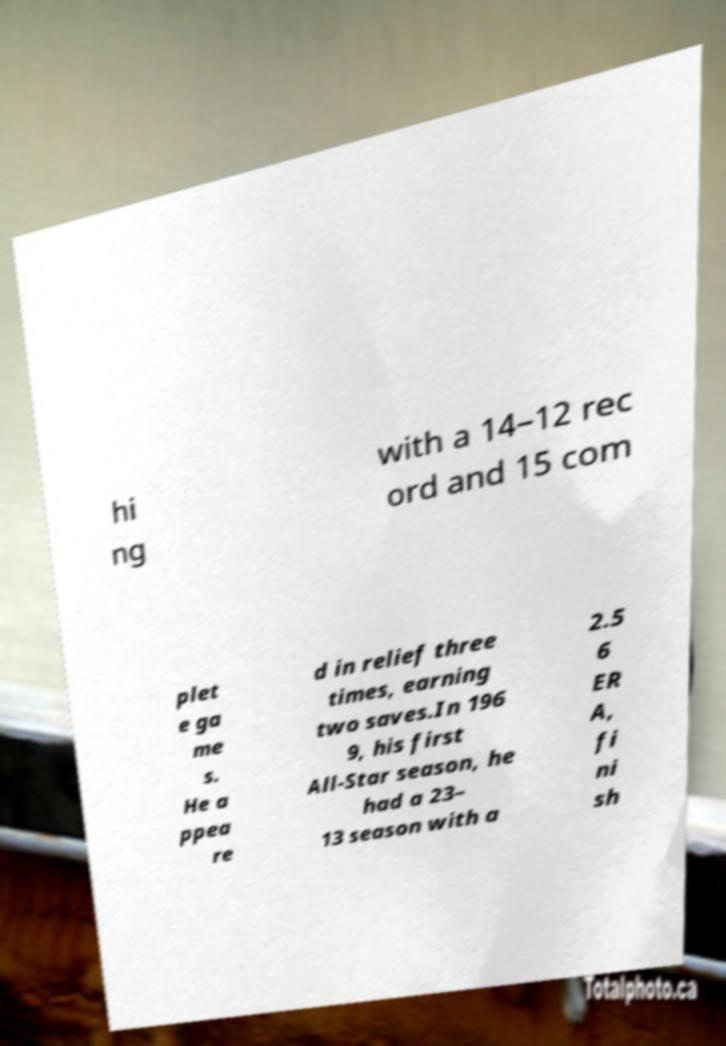Please read and relay the text visible in this image. What does it say? hi ng with a 14–12 rec ord and 15 com plet e ga me s. He a ppea re d in relief three times, earning two saves.In 196 9, his first All-Star season, he had a 23– 13 season with a 2.5 6 ER A, fi ni sh 